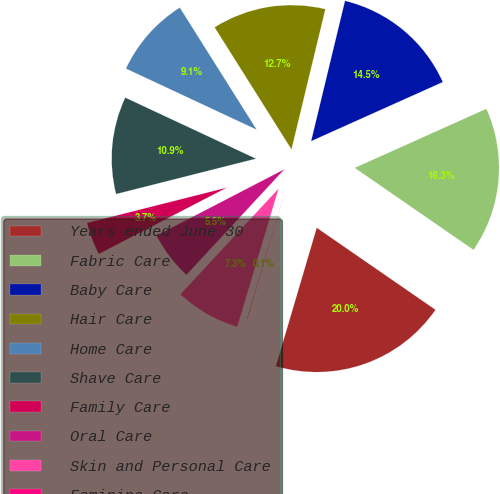<chart> <loc_0><loc_0><loc_500><loc_500><pie_chart><fcel>Years ended June 30<fcel>Fabric Care<fcel>Baby Care<fcel>Hair Care<fcel>Home Care<fcel>Shave Care<fcel>Family Care<fcel>Oral Care<fcel>Skin and Personal Care<fcel>Feminine Care<nl><fcel>19.95%<fcel>16.33%<fcel>14.52%<fcel>12.71%<fcel>9.1%<fcel>10.9%<fcel>3.67%<fcel>5.48%<fcel>7.29%<fcel>0.05%<nl></chart> 